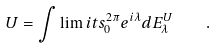Convert formula to latex. <formula><loc_0><loc_0><loc_500><loc_500>U = \int \lim i t s _ { 0 } ^ { 2 \pi } e ^ { i \lambda } d E _ { \lambda } ^ { U } \quad .</formula> 